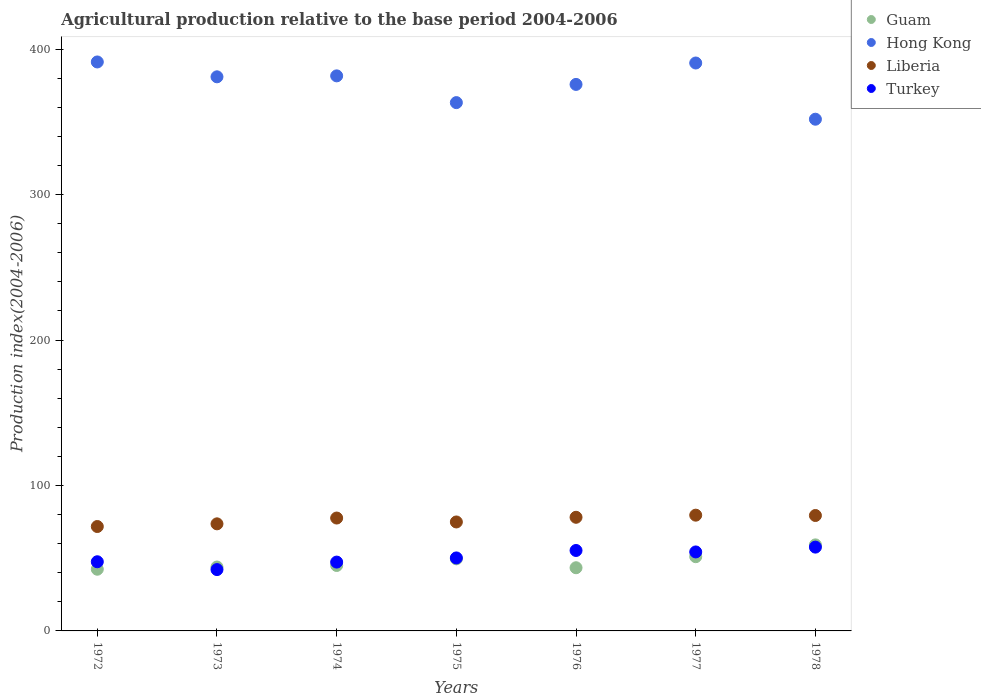How many different coloured dotlines are there?
Provide a short and direct response. 4. What is the agricultural production index in Hong Kong in 1975?
Provide a short and direct response. 363.27. Across all years, what is the maximum agricultural production index in Hong Kong?
Ensure brevity in your answer.  391.23. Across all years, what is the minimum agricultural production index in Liberia?
Make the answer very short. 71.79. What is the total agricultural production index in Hong Kong in the graph?
Your response must be concise. 2635.34. What is the difference between the agricultural production index in Liberia in 1974 and that in 1976?
Keep it short and to the point. -0.52. What is the difference between the agricultural production index in Turkey in 1975 and the agricultural production index in Guam in 1976?
Your answer should be very brief. 6.75. What is the average agricultural production index in Turkey per year?
Make the answer very short. 50.64. In the year 1975, what is the difference between the agricultural production index in Guam and agricultural production index in Hong Kong?
Ensure brevity in your answer.  -313.69. In how many years, is the agricultural production index in Guam greater than 240?
Ensure brevity in your answer.  0. What is the ratio of the agricultural production index in Hong Kong in 1974 to that in 1976?
Make the answer very short. 1.02. Is the agricultural production index in Liberia in 1977 less than that in 1978?
Provide a short and direct response. No. What is the difference between the highest and the second highest agricultural production index in Turkey?
Your answer should be compact. 2.31. What is the difference between the highest and the lowest agricultural production index in Guam?
Offer a terse response. 16.74. Is the sum of the agricultural production index in Liberia in 1974 and 1976 greater than the maximum agricultural production index in Guam across all years?
Offer a very short reply. Yes. Does the agricultural production index in Guam monotonically increase over the years?
Keep it short and to the point. No. How many years are there in the graph?
Your answer should be compact. 7. What is the difference between two consecutive major ticks on the Y-axis?
Offer a terse response. 100. Does the graph contain any zero values?
Your answer should be very brief. No. Does the graph contain grids?
Make the answer very short. No. Where does the legend appear in the graph?
Give a very brief answer. Top right. How many legend labels are there?
Provide a short and direct response. 4. What is the title of the graph?
Your answer should be compact. Agricultural production relative to the base period 2004-2006. What is the label or title of the Y-axis?
Provide a short and direct response. Production index(2004-2006). What is the Production index(2004-2006) in Guam in 1972?
Your answer should be compact. 42.42. What is the Production index(2004-2006) of Hong Kong in 1972?
Your answer should be compact. 391.23. What is the Production index(2004-2006) in Liberia in 1972?
Provide a succinct answer. 71.79. What is the Production index(2004-2006) in Turkey in 1972?
Provide a succinct answer. 47.56. What is the Production index(2004-2006) of Guam in 1973?
Make the answer very short. 43.94. What is the Production index(2004-2006) of Hong Kong in 1973?
Offer a terse response. 381.01. What is the Production index(2004-2006) of Liberia in 1973?
Your response must be concise. 73.63. What is the Production index(2004-2006) in Turkey in 1973?
Your response must be concise. 42.17. What is the Production index(2004-2006) in Guam in 1974?
Provide a succinct answer. 45. What is the Production index(2004-2006) of Hong Kong in 1974?
Offer a very short reply. 381.67. What is the Production index(2004-2006) in Liberia in 1974?
Your answer should be compact. 77.62. What is the Production index(2004-2006) of Turkey in 1974?
Ensure brevity in your answer.  47.33. What is the Production index(2004-2006) of Guam in 1975?
Your response must be concise. 49.58. What is the Production index(2004-2006) in Hong Kong in 1975?
Your response must be concise. 363.27. What is the Production index(2004-2006) in Liberia in 1975?
Provide a succinct answer. 74.92. What is the Production index(2004-2006) of Turkey in 1975?
Offer a terse response. 50.19. What is the Production index(2004-2006) of Guam in 1976?
Ensure brevity in your answer.  43.44. What is the Production index(2004-2006) of Hong Kong in 1976?
Ensure brevity in your answer.  375.79. What is the Production index(2004-2006) in Liberia in 1976?
Provide a succinct answer. 78.14. What is the Production index(2004-2006) in Turkey in 1976?
Offer a terse response. 55.31. What is the Production index(2004-2006) in Guam in 1977?
Provide a succinct answer. 51.04. What is the Production index(2004-2006) of Hong Kong in 1977?
Give a very brief answer. 390.51. What is the Production index(2004-2006) of Liberia in 1977?
Provide a short and direct response. 79.6. What is the Production index(2004-2006) of Turkey in 1977?
Provide a short and direct response. 54.31. What is the Production index(2004-2006) of Guam in 1978?
Ensure brevity in your answer.  59.16. What is the Production index(2004-2006) of Hong Kong in 1978?
Make the answer very short. 351.86. What is the Production index(2004-2006) in Liberia in 1978?
Ensure brevity in your answer.  79.36. What is the Production index(2004-2006) in Turkey in 1978?
Your answer should be very brief. 57.62. Across all years, what is the maximum Production index(2004-2006) of Guam?
Provide a short and direct response. 59.16. Across all years, what is the maximum Production index(2004-2006) of Hong Kong?
Offer a very short reply. 391.23. Across all years, what is the maximum Production index(2004-2006) in Liberia?
Your response must be concise. 79.6. Across all years, what is the maximum Production index(2004-2006) in Turkey?
Your answer should be very brief. 57.62. Across all years, what is the minimum Production index(2004-2006) in Guam?
Ensure brevity in your answer.  42.42. Across all years, what is the minimum Production index(2004-2006) of Hong Kong?
Provide a short and direct response. 351.86. Across all years, what is the minimum Production index(2004-2006) of Liberia?
Keep it short and to the point. 71.79. Across all years, what is the minimum Production index(2004-2006) of Turkey?
Your response must be concise. 42.17. What is the total Production index(2004-2006) in Guam in the graph?
Offer a terse response. 334.58. What is the total Production index(2004-2006) of Hong Kong in the graph?
Offer a terse response. 2635.34. What is the total Production index(2004-2006) in Liberia in the graph?
Ensure brevity in your answer.  535.06. What is the total Production index(2004-2006) in Turkey in the graph?
Your answer should be very brief. 354.49. What is the difference between the Production index(2004-2006) of Guam in 1972 and that in 1973?
Keep it short and to the point. -1.52. What is the difference between the Production index(2004-2006) of Hong Kong in 1972 and that in 1973?
Offer a terse response. 10.22. What is the difference between the Production index(2004-2006) of Liberia in 1972 and that in 1973?
Provide a short and direct response. -1.84. What is the difference between the Production index(2004-2006) of Turkey in 1972 and that in 1973?
Provide a succinct answer. 5.39. What is the difference between the Production index(2004-2006) of Guam in 1972 and that in 1974?
Offer a very short reply. -2.58. What is the difference between the Production index(2004-2006) in Hong Kong in 1972 and that in 1974?
Offer a terse response. 9.56. What is the difference between the Production index(2004-2006) of Liberia in 1972 and that in 1974?
Offer a terse response. -5.83. What is the difference between the Production index(2004-2006) in Turkey in 1972 and that in 1974?
Offer a terse response. 0.23. What is the difference between the Production index(2004-2006) in Guam in 1972 and that in 1975?
Your answer should be compact. -7.16. What is the difference between the Production index(2004-2006) in Hong Kong in 1972 and that in 1975?
Your response must be concise. 27.96. What is the difference between the Production index(2004-2006) of Liberia in 1972 and that in 1975?
Make the answer very short. -3.13. What is the difference between the Production index(2004-2006) in Turkey in 1972 and that in 1975?
Your answer should be compact. -2.63. What is the difference between the Production index(2004-2006) in Guam in 1972 and that in 1976?
Ensure brevity in your answer.  -1.02. What is the difference between the Production index(2004-2006) of Hong Kong in 1972 and that in 1976?
Offer a terse response. 15.44. What is the difference between the Production index(2004-2006) of Liberia in 1972 and that in 1976?
Your answer should be compact. -6.35. What is the difference between the Production index(2004-2006) in Turkey in 1972 and that in 1976?
Make the answer very short. -7.75. What is the difference between the Production index(2004-2006) in Guam in 1972 and that in 1977?
Give a very brief answer. -8.62. What is the difference between the Production index(2004-2006) of Hong Kong in 1972 and that in 1977?
Provide a short and direct response. 0.72. What is the difference between the Production index(2004-2006) of Liberia in 1972 and that in 1977?
Offer a terse response. -7.81. What is the difference between the Production index(2004-2006) of Turkey in 1972 and that in 1977?
Keep it short and to the point. -6.75. What is the difference between the Production index(2004-2006) in Guam in 1972 and that in 1978?
Ensure brevity in your answer.  -16.74. What is the difference between the Production index(2004-2006) of Hong Kong in 1972 and that in 1978?
Provide a short and direct response. 39.37. What is the difference between the Production index(2004-2006) in Liberia in 1972 and that in 1978?
Your response must be concise. -7.57. What is the difference between the Production index(2004-2006) in Turkey in 1972 and that in 1978?
Make the answer very short. -10.06. What is the difference between the Production index(2004-2006) in Guam in 1973 and that in 1974?
Your answer should be compact. -1.06. What is the difference between the Production index(2004-2006) of Hong Kong in 1973 and that in 1974?
Make the answer very short. -0.66. What is the difference between the Production index(2004-2006) in Liberia in 1973 and that in 1974?
Offer a terse response. -3.99. What is the difference between the Production index(2004-2006) of Turkey in 1973 and that in 1974?
Provide a short and direct response. -5.16. What is the difference between the Production index(2004-2006) in Guam in 1973 and that in 1975?
Offer a very short reply. -5.64. What is the difference between the Production index(2004-2006) of Hong Kong in 1973 and that in 1975?
Your answer should be very brief. 17.74. What is the difference between the Production index(2004-2006) of Liberia in 1973 and that in 1975?
Your answer should be very brief. -1.29. What is the difference between the Production index(2004-2006) in Turkey in 1973 and that in 1975?
Make the answer very short. -8.02. What is the difference between the Production index(2004-2006) of Hong Kong in 1973 and that in 1976?
Your answer should be compact. 5.22. What is the difference between the Production index(2004-2006) in Liberia in 1973 and that in 1976?
Provide a short and direct response. -4.51. What is the difference between the Production index(2004-2006) in Turkey in 1973 and that in 1976?
Keep it short and to the point. -13.14. What is the difference between the Production index(2004-2006) in Liberia in 1973 and that in 1977?
Provide a succinct answer. -5.97. What is the difference between the Production index(2004-2006) in Turkey in 1973 and that in 1977?
Keep it short and to the point. -12.14. What is the difference between the Production index(2004-2006) in Guam in 1973 and that in 1978?
Ensure brevity in your answer.  -15.22. What is the difference between the Production index(2004-2006) of Hong Kong in 1973 and that in 1978?
Keep it short and to the point. 29.15. What is the difference between the Production index(2004-2006) of Liberia in 1973 and that in 1978?
Offer a very short reply. -5.73. What is the difference between the Production index(2004-2006) in Turkey in 1973 and that in 1978?
Keep it short and to the point. -15.45. What is the difference between the Production index(2004-2006) in Guam in 1974 and that in 1975?
Your answer should be very brief. -4.58. What is the difference between the Production index(2004-2006) of Turkey in 1974 and that in 1975?
Make the answer very short. -2.86. What is the difference between the Production index(2004-2006) of Guam in 1974 and that in 1976?
Keep it short and to the point. 1.56. What is the difference between the Production index(2004-2006) of Hong Kong in 1974 and that in 1976?
Offer a terse response. 5.88. What is the difference between the Production index(2004-2006) in Liberia in 1974 and that in 1976?
Your response must be concise. -0.52. What is the difference between the Production index(2004-2006) of Turkey in 1974 and that in 1976?
Give a very brief answer. -7.98. What is the difference between the Production index(2004-2006) of Guam in 1974 and that in 1977?
Provide a succinct answer. -6.04. What is the difference between the Production index(2004-2006) of Hong Kong in 1974 and that in 1977?
Offer a very short reply. -8.84. What is the difference between the Production index(2004-2006) in Liberia in 1974 and that in 1977?
Provide a short and direct response. -1.98. What is the difference between the Production index(2004-2006) of Turkey in 1974 and that in 1977?
Provide a short and direct response. -6.98. What is the difference between the Production index(2004-2006) in Guam in 1974 and that in 1978?
Your answer should be compact. -14.16. What is the difference between the Production index(2004-2006) in Hong Kong in 1974 and that in 1978?
Keep it short and to the point. 29.81. What is the difference between the Production index(2004-2006) in Liberia in 1974 and that in 1978?
Your answer should be compact. -1.74. What is the difference between the Production index(2004-2006) in Turkey in 1974 and that in 1978?
Give a very brief answer. -10.29. What is the difference between the Production index(2004-2006) of Guam in 1975 and that in 1976?
Offer a terse response. 6.14. What is the difference between the Production index(2004-2006) in Hong Kong in 1975 and that in 1976?
Your answer should be compact. -12.52. What is the difference between the Production index(2004-2006) in Liberia in 1975 and that in 1976?
Your answer should be compact. -3.22. What is the difference between the Production index(2004-2006) of Turkey in 1975 and that in 1976?
Give a very brief answer. -5.12. What is the difference between the Production index(2004-2006) of Guam in 1975 and that in 1977?
Offer a terse response. -1.46. What is the difference between the Production index(2004-2006) in Hong Kong in 1975 and that in 1977?
Offer a terse response. -27.24. What is the difference between the Production index(2004-2006) in Liberia in 1975 and that in 1977?
Provide a succinct answer. -4.68. What is the difference between the Production index(2004-2006) in Turkey in 1975 and that in 1977?
Offer a terse response. -4.12. What is the difference between the Production index(2004-2006) of Guam in 1975 and that in 1978?
Your answer should be compact. -9.58. What is the difference between the Production index(2004-2006) in Hong Kong in 1975 and that in 1978?
Make the answer very short. 11.41. What is the difference between the Production index(2004-2006) of Liberia in 1975 and that in 1978?
Your answer should be compact. -4.44. What is the difference between the Production index(2004-2006) of Turkey in 1975 and that in 1978?
Your response must be concise. -7.43. What is the difference between the Production index(2004-2006) in Hong Kong in 1976 and that in 1977?
Offer a terse response. -14.72. What is the difference between the Production index(2004-2006) in Liberia in 1976 and that in 1977?
Keep it short and to the point. -1.46. What is the difference between the Production index(2004-2006) of Turkey in 1976 and that in 1977?
Provide a succinct answer. 1. What is the difference between the Production index(2004-2006) in Guam in 1976 and that in 1978?
Offer a terse response. -15.72. What is the difference between the Production index(2004-2006) of Hong Kong in 1976 and that in 1978?
Provide a succinct answer. 23.93. What is the difference between the Production index(2004-2006) in Liberia in 1976 and that in 1978?
Provide a short and direct response. -1.22. What is the difference between the Production index(2004-2006) in Turkey in 1976 and that in 1978?
Offer a very short reply. -2.31. What is the difference between the Production index(2004-2006) in Guam in 1977 and that in 1978?
Offer a terse response. -8.12. What is the difference between the Production index(2004-2006) of Hong Kong in 1977 and that in 1978?
Your answer should be compact. 38.65. What is the difference between the Production index(2004-2006) of Liberia in 1977 and that in 1978?
Give a very brief answer. 0.24. What is the difference between the Production index(2004-2006) in Turkey in 1977 and that in 1978?
Your answer should be compact. -3.31. What is the difference between the Production index(2004-2006) in Guam in 1972 and the Production index(2004-2006) in Hong Kong in 1973?
Offer a terse response. -338.59. What is the difference between the Production index(2004-2006) of Guam in 1972 and the Production index(2004-2006) of Liberia in 1973?
Give a very brief answer. -31.21. What is the difference between the Production index(2004-2006) of Hong Kong in 1972 and the Production index(2004-2006) of Liberia in 1973?
Ensure brevity in your answer.  317.6. What is the difference between the Production index(2004-2006) of Hong Kong in 1972 and the Production index(2004-2006) of Turkey in 1973?
Your response must be concise. 349.06. What is the difference between the Production index(2004-2006) of Liberia in 1972 and the Production index(2004-2006) of Turkey in 1973?
Offer a very short reply. 29.62. What is the difference between the Production index(2004-2006) in Guam in 1972 and the Production index(2004-2006) in Hong Kong in 1974?
Your answer should be very brief. -339.25. What is the difference between the Production index(2004-2006) of Guam in 1972 and the Production index(2004-2006) of Liberia in 1974?
Keep it short and to the point. -35.2. What is the difference between the Production index(2004-2006) of Guam in 1972 and the Production index(2004-2006) of Turkey in 1974?
Ensure brevity in your answer.  -4.91. What is the difference between the Production index(2004-2006) of Hong Kong in 1972 and the Production index(2004-2006) of Liberia in 1974?
Ensure brevity in your answer.  313.61. What is the difference between the Production index(2004-2006) in Hong Kong in 1972 and the Production index(2004-2006) in Turkey in 1974?
Your response must be concise. 343.9. What is the difference between the Production index(2004-2006) in Liberia in 1972 and the Production index(2004-2006) in Turkey in 1974?
Your answer should be compact. 24.46. What is the difference between the Production index(2004-2006) of Guam in 1972 and the Production index(2004-2006) of Hong Kong in 1975?
Offer a terse response. -320.85. What is the difference between the Production index(2004-2006) of Guam in 1972 and the Production index(2004-2006) of Liberia in 1975?
Offer a very short reply. -32.5. What is the difference between the Production index(2004-2006) of Guam in 1972 and the Production index(2004-2006) of Turkey in 1975?
Ensure brevity in your answer.  -7.77. What is the difference between the Production index(2004-2006) in Hong Kong in 1972 and the Production index(2004-2006) in Liberia in 1975?
Provide a short and direct response. 316.31. What is the difference between the Production index(2004-2006) of Hong Kong in 1972 and the Production index(2004-2006) of Turkey in 1975?
Your response must be concise. 341.04. What is the difference between the Production index(2004-2006) of Liberia in 1972 and the Production index(2004-2006) of Turkey in 1975?
Your answer should be very brief. 21.6. What is the difference between the Production index(2004-2006) of Guam in 1972 and the Production index(2004-2006) of Hong Kong in 1976?
Your answer should be very brief. -333.37. What is the difference between the Production index(2004-2006) in Guam in 1972 and the Production index(2004-2006) in Liberia in 1976?
Provide a succinct answer. -35.72. What is the difference between the Production index(2004-2006) in Guam in 1972 and the Production index(2004-2006) in Turkey in 1976?
Your answer should be very brief. -12.89. What is the difference between the Production index(2004-2006) of Hong Kong in 1972 and the Production index(2004-2006) of Liberia in 1976?
Your answer should be very brief. 313.09. What is the difference between the Production index(2004-2006) in Hong Kong in 1972 and the Production index(2004-2006) in Turkey in 1976?
Give a very brief answer. 335.92. What is the difference between the Production index(2004-2006) in Liberia in 1972 and the Production index(2004-2006) in Turkey in 1976?
Keep it short and to the point. 16.48. What is the difference between the Production index(2004-2006) of Guam in 1972 and the Production index(2004-2006) of Hong Kong in 1977?
Give a very brief answer. -348.09. What is the difference between the Production index(2004-2006) of Guam in 1972 and the Production index(2004-2006) of Liberia in 1977?
Provide a succinct answer. -37.18. What is the difference between the Production index(2004-2006) in Guam in 1972 and the Production index(2004-2006) in Turkey in 1977?
Offer a very short reply. -11.89. What is the difference between the Production index(2004-2006) of Hong Kong in 1972 and the Production index(2004-2006) of Liberia in 1977?
Ensure brevity in your answer.  311.63. What is the difference between the Production index(2004-2006) of Hong Kong in 1972 and the Production index(2004-2006) of Turkey in 1977?
Offer a very short reply. 336.92. What is the difference between the Production index(2004-2006) in Liberia in 1972 and the Production index(2004-2006) in Turkey in 1977?
Ensure brevity in your answer.  17.48. What is the difference between the Production index(2004-2006) in Guam in 1972 and the Production index(2004-2006) in Hong Kong in 1978?
Your answer should be very brief. -309.44. What is the difference between the Production index(2004-2006) in Guam in 1972 and the Production index(2004-2006) in Liberia in 1978?
Offer a terse response. -36.94. What is the difference between the Production index(2004-2006) in Guam in 1972 and the Production index(2004-2006) in Turkey in 1978?
Your answer should be compact. -15.2. What is the difference between the Production index(2004-2006) of Hong Kong in 1972 and the Production index(2004-2006) of Liberia in 1978?
Give a very brief answer. 311.87. What is the difference between the Production index(2004-2006) in Hong Kong in 1972 and the Production index(2004-2006) in Turkey in 1978?
Offer a very short reply. 333.61. What is the difference between the Production index(2004-2006) of Liberia in 1972 and the Production index(2004-2006) of Turkey in 1978?
Make the answer very short. 14.17. What is the difference between the Production index(2004-2006) in Guam in 1973 and the Production index(2004-2006) in Hong Kong in 1974?
Give a very brief answer. -337.73. What is the difference between the Production index(2004-2006) in Guam in 1973 and the Production index(2004-2006) in Liberia in 1974?
Your answer should be very brief. -33.68. What is the difference between the Production index(2004-2006) of Guam in 1973 and the Production index(2004-2006) of Turkey in 1974?
Offer a terse response. -3.39. What is the difference between the Production index(2004-2006) of Hong Kong in 1973 and the Production index(2004-2006) of Liberia in 1974?
Ensure brevity in your answer.  303.39. What is the difference between the Production index(2004-2006) in Hong Kong in 1973 and the Production index(2004-2006) in Turkey in 1974?
Provide a succinct answer. 333.68. What is the difference between the Production index(2004-2006) of Liberia in 1973 and the Production index(2004-2006) of Turkey in 1974?
Provide a short and direct response. 26.3. What is the difference between the Production index(2004-2006) in Guam in 1973 and the Production index(2004-2006) in Hong Kong in 1975?
Offer a terse response. -319.33. What is the difference between the Production index(2004-2006) of Guam in 1973 and the Production index(2004-2006) of Liberia in 1975?
Keep it short and to the point. -30.98. What is the difference between the Production index(2004-2006) of Guam in 1973 and the Production index(2004-2006) of Turkey in 1975?
Your response must be concise. -6.25. What is the difference between the Production index(2004-2006) of Hong Kong in 1973 and the Production index(2004-2006) of Liberia in 1975?
Make the answer very short. 306.09. What is the difference between the Production index(2004-2006) of Hong Kong in 1973 and the Production index(2004-2006) of Turkey in 1975?
Your response must be concise. 330.82. What is the difference between the Production index(2004-2006) in Liberia in 1973 and the Production index(2004-2006) in Turkey in 1975?
Your response must be concise. 23.44. What is the difference between the Production index(2004-2006) in Guam in 1973 and the Production index(2004-2006) in Hong Kong in 1976?
Ensure brevity in your answer.  -331.85. What is the difference between the Production index(2004-2006) in Guam in 1973 and the Production index(2004-2006) in Liberia in 1976?
Your response must be concise. -34.2. What is the difference between the Production index(2004-2006) of Guam in 1973 and the Production index(2004-2006) of Turkey in 1976?
Ensure brevity in your answer.  -11.37. What is the difference between the Production index(2004-2006) of Hong Kong in 1973 and the Production index(2004-2006) of Liberia in 1976?
Keep it short and to the point. 302.87. What is the difference between the Production index(2004-2006) in Hong Kong in 1973 and the Production index(2004-2006) in Turkey in 1976?
Your answer should be very brief. 325.7. What is the difference between the Production index(2004-2006) in Liberia in 1973 and the Production index(2004-2006) in Turkey in 1976?
Offer a terse response. 18.32. What is the difference between the Production index(2004-2006) in Guam in 1973 and the Production index(2004-2006) in Hong Kong in 1977?
Provide a succinct answer. -346.57. What is the difference between the Production index(2004-2006) in Guam in 1973 and the Production index(2004-2006) in Liberia in 1977?
Your answer should be compact. -35.66. What is the difference between the Production index(2004-2006) in Guam in 1973 and the Production index(2004-2006) in Turkey in 1977?
Ensure brevity in your answer.  -10.37. What is the difference between the Production index(2004-2006) in Hong Kong in 1973 and the Production index(2004-2006) in Liberia in 1977?
Offer a terse response. 301.41. What is the difference between the Production index(2004-2006) in Hong Kong in 1973 and the Production index(2004-2006) in Turkey in 1977?
Offer a very short reply. 326.7. What is the difference between the Production index(2004-2006) in Liberia in 1973 and the Production index(2004-2006) in Turkey in 1977?
Your answer should be compact. 19.32. What is the difference between the Production index(2004-2006) in Guam in 1973 and the Production index(2004-2006) in Hong Kong in 1978?
Ensure brevity in your answer.  -307.92. What is the difference between the Production index(2004-2006) of Guam in 1973 and the Production index(2004-2006) of Liberia in 1978?
Your response must be concise. -35.42. What is the difference between the Production index(2004-2006) in Guam in 1973 and the Production index(2004-2006) in Turkey in 1978?
Offer a terse response. -13.68. What is the difference between the Production index(2004-2006) in Hong Kong in 1973 and the Production index(2004-2006) in Liberia in 1978?
Give a very brief answer. 301.65. What is the difference between the Production index(2004-2006) of Hong Kong in 1973 and the Production index(2004-2006) of Turkey in 1978?
Your response must be concise. 323.39. What is the difference between the Production index(2004-2006) of Liberia in 1973 and the Production index(2004-2006) of Turkey in 1978?
Provide a succinct answer. 16.01. What is the difference between the Production index(2004-2006) in Guam in 1974 and the Production index(2004-2006) in Hong Kong in 1975?
Make the answer very short. -318.27. What is the difference between the Production index(2004-2006) of Guam in 1974 and the Production index(2004-2006) of Liberia in 1975?
Offer a very short reply. -29.92. What is the difference between the Production index(2004-2006) in Guam in 1974 and the Production index(2004-2006) in Turkey in 1975?
Your answer should be very brief. -5.19. What is the difference between the Production index(2004-2006) in Hong Kong in 1974 and the Production index(2004-2006) in Liberia in 1975?
Ensure brevity in your answer.  306.75. What is the difference between the Production index(2004-2006) in Hong Kong in 1974 and the Production index(2004-2006) in Turkey in 1975?
Your response must be concise. 331.48. What is the difference between the Production index(2004-2006) of Liberia in 1974 and the Production index(2004-2006) of Turkey in 1975?
Your response must be concise. 27.43. What is the difference between the Production index(2004-2006) in Guam in 1974 and the Production index(2004-2006) in Hong Kong in 1976?
Your response must be concise. -330.79. What is the difference between the Production index(2004-2006) in Guam in 1974 and the Production index(2004-2006) in Liberia in 1976?
Give a very brief answer. -33.14. What is the difference between the Production index(2004-2006) in Guam in 1974 and the Production index(2004-2006) in Turkey in 1976?
Your answer should be very brief. -10.31. What is the difference between the Production index(2004-2006) in Hong Kong in 1974 and the Production index(2004-2006) in Liberia in 1976?
Your response must be concise. 303.53. What is the difference between the Production index(2004-2006) of Hong Kong in 1974 and the Production index(2004-2006) of Turkey in 1976?
Ensure brevity in your answer.  326.36. What is the difference between the Production index(2004-2006) in Liberia in 1974 and the Production index(2004-2006) in Turkey in 1976?
Offer a very short reply. 22.31. What is the difference between the Production index(2004-2006) of Guam in 1974 and the Production index(2004-2006) of Hong Kong in 1977?
Provide a short and direct response. -345.51. What is the difference between the Production index(2004-2006) of Guam in 1974 and the Production index(2004-2006) of Liberia in 1977?
Offer a terse response. -34.6. What is the difference between the Production index(2004-2006) of Guam in 1974 and the Production index(2004-2006) of Turkey in 1977?
Keep it short and to the point. -9.31. What is the difference between the Production index(2004-2006) in Hong Kong in 1974 and the Production index(2004-2006) in Liberia in 1977?
Ensure brevity in your answer.  302.07. What is the difference between the Production index(2004-2006) of Hong Kong in 1974 and the Production index(2004-2006) of Turkey in 1977?
Ensure brevity in your answer.  327.36. What is the difference between the Production index(2004-2006) of Liberia in 1974 and the Production index(2004-2006) of Turkey in 1977?
Keep it short and to the point. 23.31. What is the difference between the Production index(2004-2006) in Guam in 1974 and the Production index(2004-2006) in Hong Kong in 1978?
Offer a terse response. -306.86. What is the difference between the Production index(2004-2006) of Guam in 1974 and the Production index(2004-2006) of Liberia in 1978?
Offer a very short reply. -34.36. What is the difference between the Production index(2004-2006) in Guam in 1974 and the Production index(2004-2006) in Turkey in 1978?
Offer a very short reply. -12.62. What is the difference between the Production index(2004-2006) in Hong Kong in 1974 and the Production index(2004-2006) in Liberia in 1978?
Provide a short and direct response. 302.31. What is the difference between the Production index(2004-2006) of Hong Kong in 1974 and the Production index(2004-2006) of Turkey in 1978?
Offer a very short reply. 324.05. What is the difference between the Production index(2004-2006) of Guam in 1975 and the Production index(2004-2006) of Hong Kong in 1976?
Your answer should be compact. -326.21. What is the difference between the Production index(2004-2006) in Guam in 1975 and the Production index(2004-2006) in Liberia in 1976?
Your answer should be compact. -28.56. What is the difference between the Production index(2004-2006) of Guam in 1975 and the Production index(2004-2006) of Turkey in 1976?
Make the answer very short. -5.73. What is the difference between the Production index(2004-2006) of Hong Kong in 1975 and the Production index(2004-2006) of Liberia in 1976?
Make the answer very short. 285.13. What is the difference between the Production index(2004-2006) in Hong Kong in 1975 and the Production index(2004-2006) in Turkey in 1976?
Offer a terse response. 307.96. What is the difference between the Production index(2004-2006) in Liberia in 1975 and the Production index(2004-2006) in Turkey in 1976?
Make the answer very short. 19.61. What is the difference between the Production index(2004-2006) of Guam in 1975 and the Production index(2004-2006) of Hong Kong in 1977?
Give a very brief answer. -340.93. What is the difference between the Production index(2004-2006) in Guam in 1975 and the Production index(2004-2006) in Liberia in 1977?
Keep it short and to the point. -30.02. What is the difference between the Production index(2004-2006) in Guam in 1975 and the Production index(2004-2006) in Turkey in 1977?
Your response must be concise. -4.73. What is the difference between the Production index(2004-2006) of Hong Kong in 1975 and the Production index(2004-2006) of Liberia in 1977?
Offer a terse response. 283.67. What is the difference between the Production index(2004-2006) in Hong Kong in 1975 and the Production index(2004-2006) in Turkey in 1977?
Make the answer very short. 308.96. What is the difference between the Production index(2004-2006) of Liberia in 1975 and the Production index(2004-2006) of Turkey in 1977?
Keep it short and to the point. 20.61. What is the difference between the Production index(2004-2006) of Guam in 1975 and the Production index(2004-2006) of Hong Kong in 1978?
Your response must be concise. -302.28. What is the difference between the Production index(2004-2006) of Guam in 1975 and the Production index(2004-2006) of Liberia in 1978?
Provide a short and direct response. -29.78. What is the difference between the Production index(2004-2006) of Guam in 1975 and the Production index(2004-2006) of Turkey in 1978?
Offer a very short reply. -8.04. What is the difference between the Production index(2004-2006) in Hong Kong in 1975 and the Production index(2004-2006) in Liberia in 1978?
Give a very brief answer. 283.91. What is the difference between the Production index(2004-2006) in Hong Kong in 1975 and the Production index(2004-2006) in Turkey in 1978?
Keep it short and to the point. 305.65. What is the difference between the Production index(2004-2006) of Liberia in 1975 and the Production index(2004-2006) of Turkey in 1978?
Make the answer very short. 17.3. What is the difference between the Production index(2004-2006) in Guam in 1976 and the Production index(2004-2006) in Hong Kong in 1977?
Provide a short and direct response. -347.07. What is the difference between the Production index(2004-2006) of Guam in 1976 and the Production index(2004-2006) of Liberia in 1977?
Offer a very short reply. -36.16. What is the difference between the Production index(2004-2006) of Guam in 1976 and the Production index(2004-2006) of Turkey in 1977?
Give a very brief answer. -10.87. What is the difference between the Production index(2004-2006) in Hong Kong in 1976 and the Production index(2004-2006) in Liberia in 1977?
Offer a very short reply. 296.19. What is the difference between the Production index(2004-2006) in Hong Kong in 1976 and the Production index(2004-2006) in Turkey in 1977?
Your answer should be compact. 321.48. What is the difference between the Production index(2004-2006) in Liberia in 1976 and the Production index(2004-2006) in Turkey in 1977?
Provide a succinct answer. 23.83. What is the difference between the Production index(2004-2006) in Guam in 1976 and the Production index(2004-2006) in Hong Kong in 1978?
Keep it short and to the point. -308.42. What is the difference between the Production index(2004-2006) of Guam in 1976 and the Production index(2004-2006) of Liberia in 1978?
Give a very brief answer. -35.92. What is the difference between the Production index(2004-2006) of Guam in 1976 and the Production index(2004-2006) of Turkey in 1978?
Offer a very short reply. -14.18. What is the difference between the Production index(2004-2006) in Hong Kong in 1976 and the Production index(2004-2006) in Liberia in 1978?
Ensure brevity in your answer.  296.43. What is the difference between the Production index(2004-2006) in Hong Kong in 1976 and the Production index(2004-2006) in Turkey in 1978?
Offer a terse response. 318.17. What is the difference between the Production index(2004-2006) of Liberia in 1976 and the Production index(2004-2006) of Turkey in 1978?
Your answer should be very brief. 20.52. What is the difference between the Production index(2004-2006) in Guam in 1977 and the Production index(2004-2006) in Hong Kong in 1978?
Your response must be concise. -300.82. What is the difference between the Production index(2004-2006) in Guam in 1977 and the Production index(2004-2006) in Liberia in 1978?
Your answer should be compact. -28.32. What is the difference between the Production index(2004-2006) in Guam in 1977 and the Production index(2004-2006) in Turkey in 1978?
Provide a succinct answer. -6.58. What is the difference between the Production index(2004-2006) in Hong Kong in 1977 and the Production index(2004-2006) in Liberia in 1978?
Your answer should be very brief. 311.15. What is the difference between the Production index(2004-2006) of Hong Kong in 1977 and the Production index(2004-2006) of Turkey in 1978?
Your answer should be compact. 332.89. What is the difference between the Production index(2004-2006) in Liberia in 1977 and the Production index(2004-2006) in Turkey in 1978?
Ensure brevity in your answer.  21.98. What is the average Production index(2004-2006) in Guam per year?
Your response must be concise. 47.8. What is the average Production index(2004-2006) in Hong Kong per year?
Your response must be concise. 376.48. What is the average Production index(2004-2006) in Liberia per year?
Keep it short and to the point. 76.44. What is the average Production index(2004-2006) of Turkey per year?
Offer a terse response. 50.64. In the year 1972, what is the difference between the Production index(2004-2006) of Guam and Production index(2004-2006) of Hong Kong?
Give a very brief answer. -348.81. In the year 1972, what is the difference between the Production index(2004-2006) in Guam and Production index(2004-2006) in Liberia?
Ensure brevity in your answer.  -29.37. In the year 1972, what is the difference between the Production index(2004-2006) in Guam and Production index(2004-2006) in Turkey?
Make the answer very short. -5.14. In the year 1972, what is the difference between the Production index(2004-2006) of Hong Kong and Production index(2004-2006) of Liberia?
Ensure brevity in your answer.  319.44. In the year 1972, what is the difference between the Production index(2004-2006) in Hong Kong and Production index(2004-2006) in Turkey?
Make the answer very short. 343.67. In the year 1972, what is the difference between the Production index(2004-2006) of Liberia and Production index(2004-2006) of Turkey?
Offer a very short reply. 24.23. In the year 1973, what is the difference between the Production index(2004-2006) of Guam and Production index(2004-2006) of Hong Kong?
Ensure brevity in your answer.  -337.07. In the year 1973, what is the difference between the Production index(2004-2006) of Guam and Production index(2004-2006) of Liberia?
Your answer should be very brief. -29.69. In the year 1973, what is the difference between the Production index(2004-2006) of Guam and Production index(2004-2006) of Turkey?
Give a very brief answer. 1.77. In the year 1973, what is the difference between the Production index(2004-2006) of Hong Kong and Production index(2004-2006) of Liberia?
Provide a short and direct response. 307.38. In the year 1973, what is the difference between the Production index(2004-2006) of Hong Kong and Production index(2004-2006) of Turkey?
Make the answer very short. 338.84. In the year 1973, what is the difference between the Production index(2004-2006) in Liberia and Production index(2004-2006) in Turkey?
Make the answer very short. 31.46. In the year 1974, what is the difference between the Production index(2004-2006) in Guam and Production index(2004-2006) in Hong Kong?
Your answer should be very brief. -336.67. In the year 1974, what is the difference between the Production index(2004-2006) of Guam and Production index(2004-2006) of Liberia?
Ensure brevity in your answer.  -32.62. In the year 1974, what is the difference between the Production index(2004-2006) in Guam and Production index(2004-2006) in Turkey?
Make the answer very short. -2.33. In the year 1974, what is the difference between the Production index(2004-2006) in Hong Kong and Production index(2004-2006) in Liberia?
Provide a succinct answer. 304.05. In the year 1974, what is the difference between the Production index(2004-2006) in Hong Kong and Production index(2004-2006) in Turkey?
Your answer should be very brief. 334.34. In the year 1974, what is the difference between the Production index(2004-2006) of Liberia and Production index(2004-2006) of Turkey?
Provide a short and direct response. 30.29. In the year 1975, what is the difference between the Production index(2004-2006) of Guam and Production index(2004-2006) of Hong Kong?
Offer a terse response. -313.69. In the year 1975, what is the difference between the Production index(2004-2006) in Guam and Production index(2004-2006) in Liberia?
Offer a very short reply. -25.34. In the year 1975, what is the difference between the Production index(2004-2006) of Guam and Production index(2004-2006) of Turkey?
Offer a very short reply. -0.61. In the year 1975, what is the difference between the Production index(2004-2006) of Hong Kong and Production index(2004-2006) of Liberia?
Your answer should be very brief. 288.35. In the year 1975, what is the difference between the Production index(2004-2006) in Hong Kong and Production index(2004-2006) in Turkey?
Provide a succinct answer. 313.08. In the year 1975, what is the difference between the Production index(2004-2006) in Liberia and Production index(2004-2006) in Turkey?
Provide a short and direct response. 24.73. In the year 1976, what is the difference between the Production index(2004-2006) of Guam and Production index(2004-2006) of Hong Kong?
Your response must be concise. -332.35. In the year 1976, what is the difference between the Production index(2004-2006) in Guam and Production index(2004-2006) in Liberia?
Offer a terse response. -34.7. In the year 1976, what is the difference between the Production index(2004-2006) of Guam and Production index(2004-2006) of Turkey?
Keep it short and to the point. -11.87. In the year 1976, what is the difference between the Production index(2004-2006) in Hong Kong and Production index(2004-2006) in Liberia?
Your answer should be very brief. 297.65. In the year 1976, what is the difference between the Production index(2004-2006) in Hong Kong and Production index(2004-2006) in Turkey?
Offer a very short reply. 320.48. In the year 1976, what is the difference between the Production index(2004-2006) in Liberia and Production index(2004-2006) in Turkey?
Your answer should be very brief. 22.83. In the year 1977, what is the difference between the Production index(2004-2006) of Guam and Production index(2004-2006) of Hong Kong?
Your response must be concise. -339.47. In the year 1977, what is the difference between the Production index(2004-2006) in Guam and Production index(2004-2006) in Liberia?
Provide a succinct answer. -28.56. In the year 1977, what is the difference between the Production index(2004-2006) in Guam and Production index(2004-2006) in Turkey?
Offer a very short reply. -3.27. In the year 1977, what is the difference between the Production index(2004-2006) in Hong Kong and Production index(2004-2006) in Liberia?
Keep it short and to the point. 310.91. In the year 1977, what is the difference between the Production index(2004-2006) in Hong Kong and Production index(2004-2006) in Turkey?
Provide a short and direct response. 336.2. In the year 1977, what is the difference between the Production index(2004-2006) of Liberia and Production index(2004-2006) of Turkey?
Ensure brevity in your answer.  25.29. In the year 1978, what is the difference between the Production index(2004-2006) in Guam and Production index(2004-2006) in Hong Kong?
Provide a succinct answer. -292.7. In the year 1978, what is the difference between the Production index(2004-2006) in Guam and Production index(2004-2006) in Liberia?
Give a very brief answer. -20.2. In the year 1978, what is the difference between the Production index(2004-2006) of Guam and Production index(2004-2006) of Turkey?
Offer a terse response. 1.54. In the year 1978, what is the difference between the Production index(2004-2006) of Hong Kong and Production index(2004-2006) of Liberia?
Your response must be concise. 272.5. In the year 1978, what is the difference between the Production index(2004-2006) in Hong Kong and Production index(2004-2006) in Turkey?
Your response must be concise. 294.24. In the year 1978, what is the difference between the Production index(2004-2006) of Liberia and Production index(2004-2006) of Turkey?
Offer a very short reply. 21.74. What is the ratio of the Production index(2004-2006) in Guam in 1972 to that in 1973?
Your answer should be compact. 0.97. What is the ratio of the Production index(2004-2006) of Hong Kong in 1972 to that in 1973?
Ensure brevity in your answer.  1.03. What is the ratio of the Production index(2004-2006) of Turkey in 1972 to that in 1973?
Ensure brevity in your answer.  1.13. What is the ratio of the Production index(2004-2006) of Guam in 1972 to that in 1974?
Offer a terse response. 0.94. What is the ratio of the Production index(2004-2006) of Hong Kong in 1972 to that in 1974?
Make the answer very short. 1.02. What is the ratio of the Production index(2004-2006) in Liberia in 1972 to that in 1974?
Your answer should be compact. 0.92. What is the ratio of the Production index(2004-2006) in Turkey in 1972 to that in 1974?
Your answer should be very brief. 1. What is the ratio of the Production index(2004-2006) of Guam in 1972 to that in 1975?
Your answer should be compact. 0.86. What is the ratio of the Production index(2004-2006) in Hong Kong in 1972 to that in 1975?
Ensure brevity in your answer.  1.08. What is the ratio of the Production index(2004-2006) of Liberia in 1972 to that in 1975?
Your answer should be compact. 0.96. What is the ratio of the Production index(2004-2006) in Turkey in 1972 to that in 1975?
Provide a short and direct response. 0.95. What is the ratio of the Production index(2004-2006) in Guam in 1972 to that in 1976?
Make the answer very short. 0.98. What is the ratio of the Production index(2004-2006) of Hong Kong in 1972 to that in 1976?
Make the answer very short. 1.04. What is the ratio of the Production index(2004-2006) in Liberia in 1972 to that in 1976?
Your answer should be very brief. 0.92. What is the ratio of the Production index(2004-2006) in Turkey in 1972 to that in 1976?
Offer a terse response. 0.86. What is the ratio of the Production index(2004-2006) of Guam in 1972 to that in 1977?
Your answer should be compact. 0.83. What is the ratio of the Production index(2004-2006) of Hong Kong in 1972 to that in 1977?
Offer a very short reply. 1. What is the ratio of the Production index(2004-2006) of Liberia in 1972 to that in 1977?
Offer a very short reply. 0.9. What is the ratio of the Production index(2004-2006) in Turkey in 1972 to that in 1977?
Give a very brief answer. 0.88. What is the ratio of the Production index(2004-2006) in Guam in 1972 to that in 1978?
Provide a short and direct response. 0.72. What is the ratio of the Production index(2004-2006) in Hong Kong in 1972 to that in 1978?
Ensure brevity in your answer.  1.11. What is the ratio of the Production index(2004-2006) in Liberia in 1972 to that in 1978?
Your answer should be very brief. 0.9. What is the ratio of the Production index(2004-2006) of Turkey in 1972 to that in 1978?
Give a very brief answer. 0.83. What is the ratio of the Production index(2004-2006) in Guam in 1973 to that in 1974?
Your answer should be very brief. 0.98. What is the ratio of the Production index(2004-2006) in Hong Kong in 1973 to that in 1974?
Make the answer very short. 1. What is the ratio of the Production index(2004-2006) in Liberia in 1973 to that in 1974?
Offer a very short reply. 0.95. What is the ratio of the Production index(2004-2006) in Turkey in 1973 to that in 1974?
Ensure brevity in your answer.  0.89. What is the ratio of the Production index(2004-2006) in Guam in 1973 to that in 1975?
Ensure brevity in your answer.  0.89. What is the ratio of the Production index(2004-2006) of Hong Kong in 1973 to that in 1975?
Ensure brevity in your answer.  1.05. What is the ratio of the Production index(2004-2006) in Liberia in 1973 to that in 1975?
Give a very brief answer. 0.98. What is the ratio of the Production index(2004-2006) in Turkey in 1973 to that in 1975?
Ensure brevity in your answer.  0.84. What is the ratio of the Production index(2004-2006) in Guam in 1973 to that in 1976?
Make the answer very short. 1.01. What is the ratio of the Production index(2004-2006) in Hong Kong in 1973 to that in 1976?
Keep it short and to the point. 1.01. What is the ratio of the Production index(2004-2006) in Liberia in 1973 to that in 1976?
Your answer should be very brief. 0.94. What is the ratio of the Production index(2004-2006) of Turkey in 1973 to that in 1976?
Provide a short and direct response. 0.76. What is the ratio of the Production index(2004-2006) in Guam in 1973 to that in 1977?
Your response must be concise. 0.86. What is the ratio of the Production index(2004-2006) in Hong Kong in 1973 to that in 1977?
Offer a very short reply. 0.98. What is the ratio of the Production index(2004-2006) in Liberia in 1973 to that in 1977?
Ensure brevity in your answer.  0.93. What is the ratio of the Production index(2004-2006) of Turkey in 1973 to that in 1977?
Offer a terse response. 0.78. What is the ratio of the Production index(2004-2006) in Guam in 1973 to that in 1978?
Your answer should be compact. 0.74. What is the ratio of the Production index(2004-2006) in Hong Kong in 1973 to that in 1978?
Make the answer very short. 1.08. What is the ratio of the Production index(2004-2006) in Liberia in 1973 to that in 1978?
Give a very brief answer. 0.93. What is the ratio of the Production index(2004-2006) of Turkey in 1973 to that in 1978?
Offer a terse response. 0.73. What is the ratio of the Production index(2004-2006) of Guam in 1974 to that in 1975?
Your answer should be compact. 0.91. What is the ratio of the Production index(2004-2006) in Hong Kong in 1974 to that in 1975?
Your answer should be compact. 1.05. What is the ratio of the Production index(2004-2006) in Liberia in 1974 to that in 1975?
Offer a very short reply. 1.04. What is the ratio of the Production index(2004-2006) of Turkey in 1974 to that in 1975?
Offer a very short reply. 0.94. What is the ratio of the Production index(2004-2006) of Guam in 1974 to that in 1976?
Offer a very short reply. 1.04. What is the ratio of the Production index(2004-2006) in Hong Kong in 1974 to that in 1976?
Your answer should be compact. 1.02. What is the ratio of the Production index(2004-2006) of Liberia in 1974 to that in 1976?
Provide a short and direct response. 0.99. What is the ratio of the Production index(2004-2006) of Turkey in 1974 to that in 1976?
Your response must be concise. 0.86. What is the ratio of the Production index(2004-2006) of Guam in 1974 to that in 1977?
Your answer should be very brief. 0.88. What is the ratio of the Production index(2004-2006) in Hong Kong in 1974 to that in 1977?
Make the answer very short. 0.98. What is the ratio of the Production index(2004-2006) of Liberia in 1974 to that in 1977?
Make the answer very short. 0.98. What is the ratio of the Production index(2004-2006) of Turkey in 1974 to that in 1977?
Ensure brevity in your answer.  0.87. What is the ratio of the Production index(2004-2006) in Guam in 1974 to that in 1978?
Make the answer very short. 0.76. What is the ratio of the Production index(2004-2006) of Hong Kong in 1974 to that in 1978?
Offer a terse response. 1.08. What is the ratio of the Production index(2004-2006) in Liberia in 1974 to that in 1978?
Make the answer very short. 0.98. What is the ratio of the Production index(2004-2006) in Turkey in 1974 to that in 1978?
Provide a succinct answer. 0.82. What is the ratio of the Production index(2004-2006) of Guam in 1975 to that in 1976?
Offer a terse response. 1.14. What is the ratio of the Production index(2004-2006) in Hong Kong in 1975 to that in 1976?
Provide a short and direct response. 0.97. What is the ratio of the Production index(2004-2006) in Liberia in 1975 to that in 1976?
Offer a very short reply. 0.96. What is the ratio of the Production index(2004-2006) in Turkey in 1975 to that in 1976?
Make the answer very short. 0.91. What is the ratio of the Production index(2004-2006) in Guam in 1975 to that in 1977?
Offer a terse response. 0.97. What is the ratio of the Production index(2004-2006) in Hong Kong in 1975 to that in 1977?
Provide a short and direct response. 0.93. What is the ratio of the Production index(2004-2006) of Turkey in 1975 to that in 1977?
Ensure brevity in your answer.  0.92. What is the ratio of the Production index(2004-2006) in Guam in 1975 to that in 1978?
Offer a very short reply. 0.84. What is the ratio of the Production index(2004-2006) in Hong Kong in 1975 to that in 1978?
Your response must be concise. 1.03. What is the ratio of the Production index(2004-2006) of Liberia in 1975 to that in 1978?
Offer a very short reply. 0.94. What is the ratio of the Production index(2004-2006) of Turkey in 1975 to that in 1978?
Ensure brevity in your answer.  0.87. What is the ratio of the Production index(2004-2006) of Guam in 1976 to that in 1977?
Provide a succinct answer. 0.85. What is the ratio of the Production index(2004-2006) of Hong Kong in 1976 to that in 1977?
Make the answer very short. 0.96. What is the ratio of the Production index(2004-2006) of Liberia in 1976 to that in 1977?
Your answer should be compact. 0.98. What is the ratio of the Production index(2004-2006) of Turkey in 1976 to that in 1977?
Your answer should be very brief. 1.02. What is the ratio of the Production index(2004-2006) of Guam in 1976 to that in 1978?
Keep it short and to the point. 0.73. What is the ratio of the Production index(2004-2006) in Hong Kong in 1976 to that in 1978?
Offer a very short reply. 1.07. What is the ratio of the Production index(2004-2006) in Liberia in 1976 to that in 1978?
Provide a short and direct response. 0.98. What is the ratio of the Production index(2004-2006) of Turkey in 1976 to that in 1978?
Your response must be concise. 0.96. What is the ratio of the Production index(2004-2006) of Guam in 1977 to that in 1978?
Your response must be concise. 0.86. What is the ratio of the Production index(2004-2006) in Hong Kong in 1977 to that in 1978?
Provide a short and direct response. 1.11. What is the ratio of the Production index(2004-2006) in Turkey in 1977 to that in 1978?
Provide a succinct answer. 0.94. What is the difference between the highest and the second highest Production index(2004-2006) of Guam?
Your answer should be compact. 8.12. What is the difference between the highest and the second highest Production index(2004-2006) of Hong Kong?
Offer a very short reply. 0.72. What is the difference between the highest and the second highest Production index(2004-2006) in Liberia?
Provide a succinct answer. 0.24. What is the difference between the highest and the second highest Production index(2004-2006) of Turkey?
Keep it short and to the point. 2.31. What is the difference between the highest and the lowest Production index(2004-2006) in Guam?
Provide a short and direct response. 16.74. What is the difference between the highest and the lowest Production index(2004-2006) in Hong Kong?
Provide a succinct answer. 39.37. What is the difference between the highest and the lowest Production index(2004-2006) of Liberia?
Give a very brief answer. 7.81. What is the difference between the highest and the lowest Production index(2004-2006) of Turkey?
Ensure brevity in your answer.  15.45. 